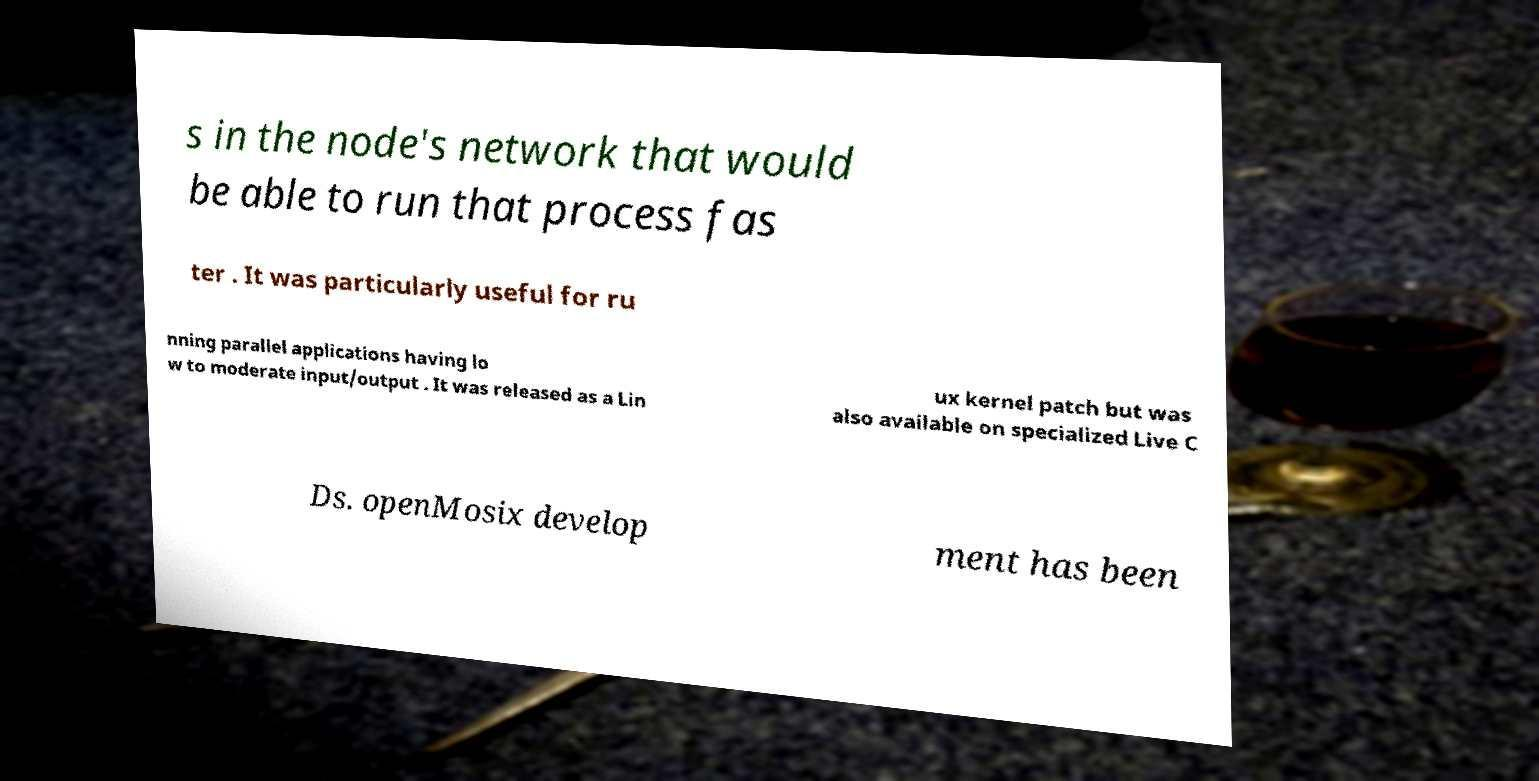I need the written content from this picture converted into text. Can you do that? s in the node's network that would be able to run that process fas ter . It was particularly useful for ru nning parallel applications having lo w to moderate input/output . It was released as a Lin ux kernel patch but was also available on specialized Live C Ds. openMosix develop ment has been 